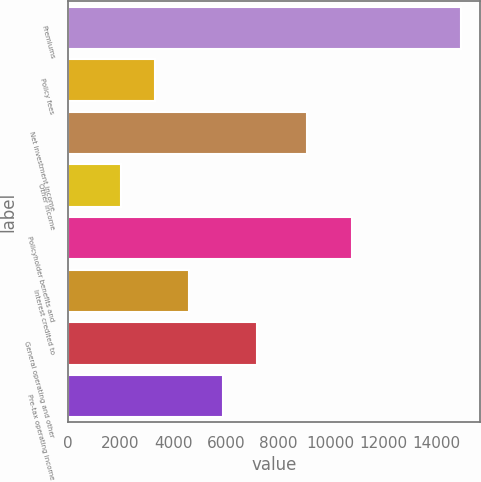Convert chart. <chart><loc_0><loc_0><loc_500><loc_500><bar_chart><fcel>Premiums<fcel>Policy fees<fcel>Net investment income<fcel>Other income<fcel>Policyholder benefits and<fcel>Interest credited to<fcel>General operating and other<fcel>Pre-tax operating income<nl><fcel>14936<fcel>3291.8<fcel>9082<fcel>1998<fcel>10796<fcel>4585.6<fcel>7173.2<fcel>5879.4<nl></chart> 